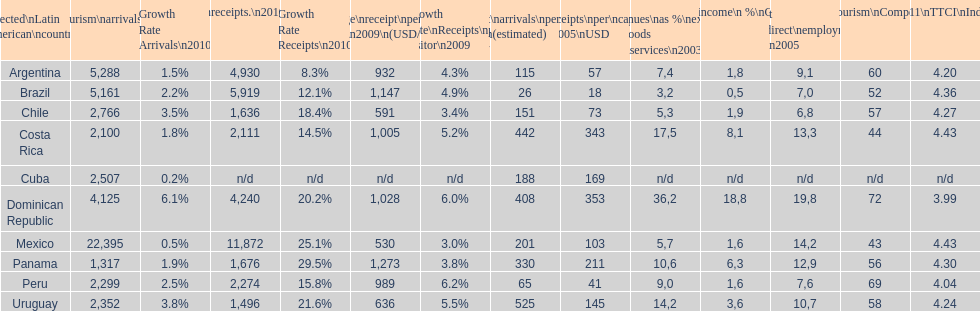What country had the most receipts per capita in 2005? Dominican Republic. 